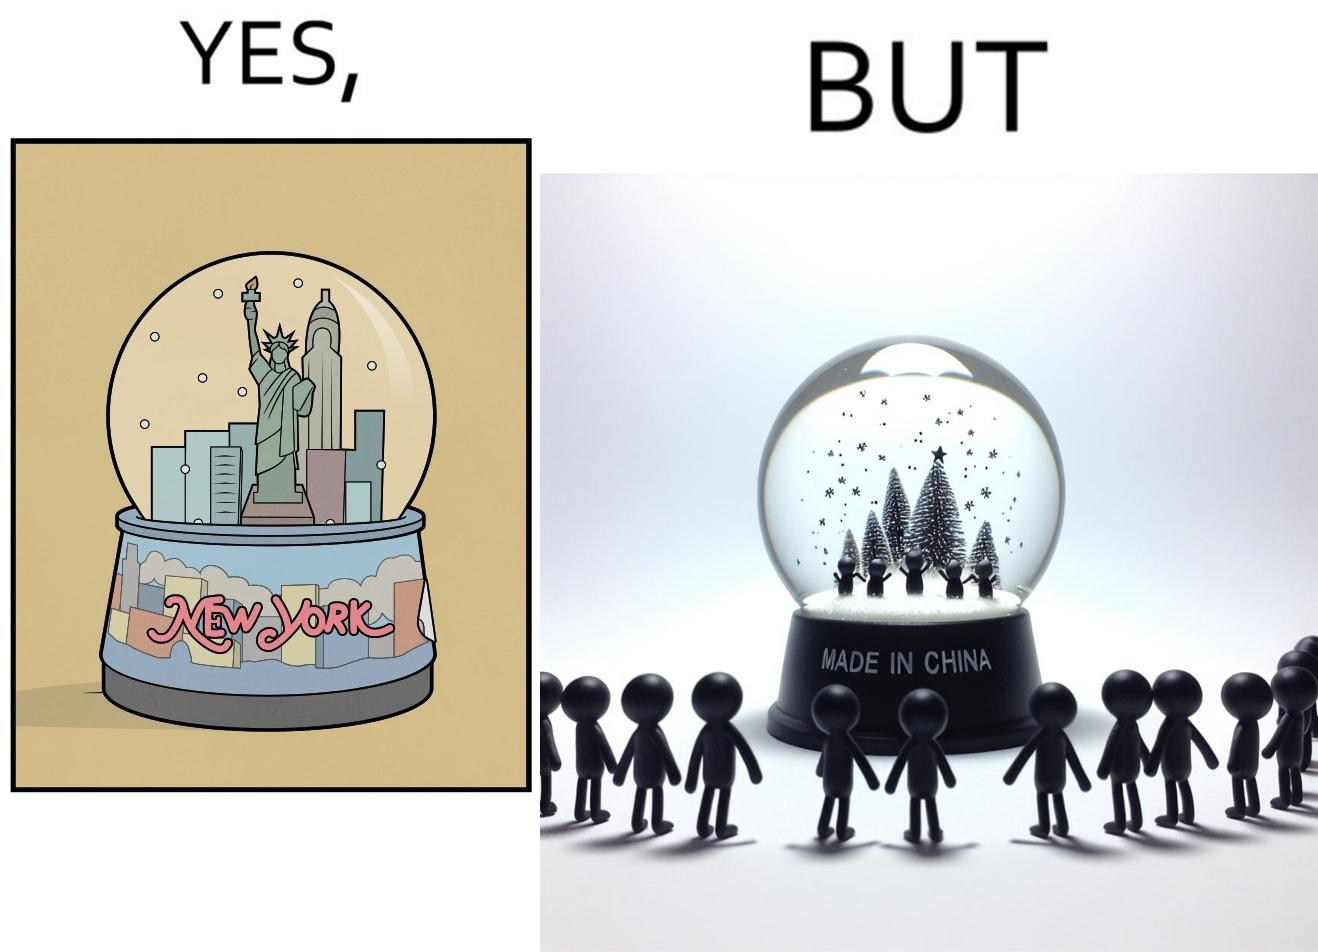Provide a description of this image. The image is ironic because the snowglobe says 'New York' while it is made in China 